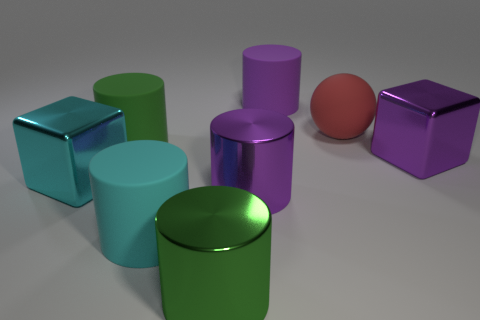Subtract all purple cylinders. How many were subtracted if there are1purple cylinders left? 1 Subtract 3 cylinders. How many cylinders are left? 2 Add 2 small yellow rubber objects. How many objects exist? 10 Subtract all cyan cylinders. How many cylinders are left? 4 Subtract all large green metal cylinders. How many cylinders are left? 4 Subtract 0 blue cubes. How many objects are left? 8 Subtract all balls. How many objects are left? 7 Subtract all purple blocks. Subtract all blue cylinders. How many blocks are left? 1 Subtract all brown cylinders. How many cyan cubes are left? 1 Subtract all red things. Subtract all tiny red matte blocks. How many objects are left? 7 